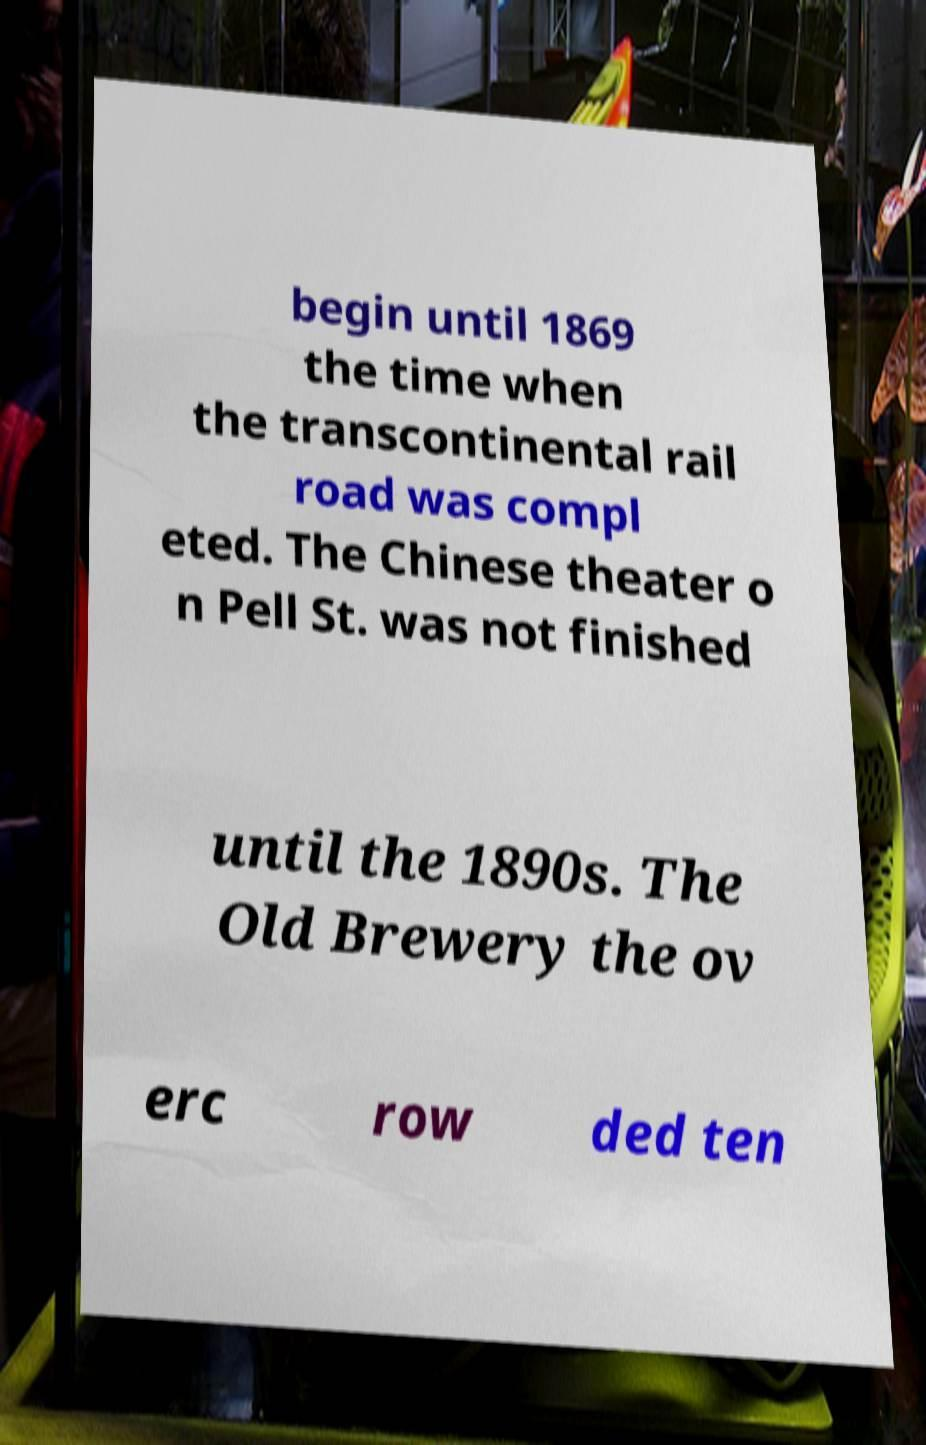Could you assist in decoding the text presented in this image and type it out clearly? begin until 1869 the time when the transcontinental rail road was compl eted. The Chinese theater o n Pell St. was not finished until the 1890s. The Old Brewery the ov erc row ded ten 